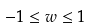<formula> <loc_0><loc_0><loc_500><loc_500>- 1 \leq w \leq 1</formula> 